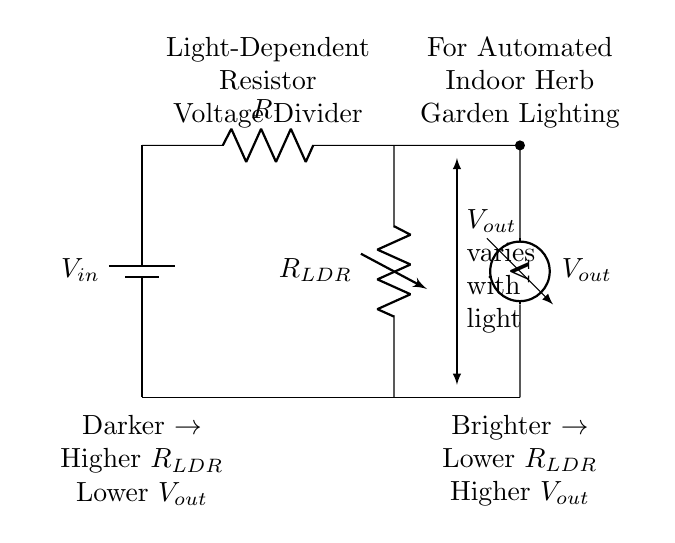What is the input voltage in the circuit? The input voltage, denoted as V-in, is specified at the source of the circuit and is illustrated next to the battery symbol.
Answer: V-in What component varies its resistance with light? The component that varies its resistance with light is labeled as R-LDR, indicating it is a light-dependent resistor.
Answer: R-LDR How does V-out change with light level? V-out changes inversely with the light level because as light increases, R-LDR decreases, resulting in a higher V-out, and vice versa.
Answer: V-out increases What is the function of resistor R1 in the circuit? R1 is a fixed resistor in the voltage divider that helps establish a reference voltage and divides the input voltage based on the resistance of R-LDR.
Answer: Reference voltage What happens to the output voltage when it is dark? In darkness, the resistance of R-LDR increases, causing V-out to decrease because the voltage drop across R-LDR becomes greater compared to R1.
Answer: V-out decreases How many total resistors are in this voltage divider configuration? There are two resistors in the voltage divider configuration, R1 and R-LDR, which together determine the output voltage.
Answer: Two What is the relationship between light and the output voltage? The relationship is direct; as the amount of light increases, the resistance R-LDR decreases, leading to an increase in the output voltage V-out.
Answer: Direct relationship 